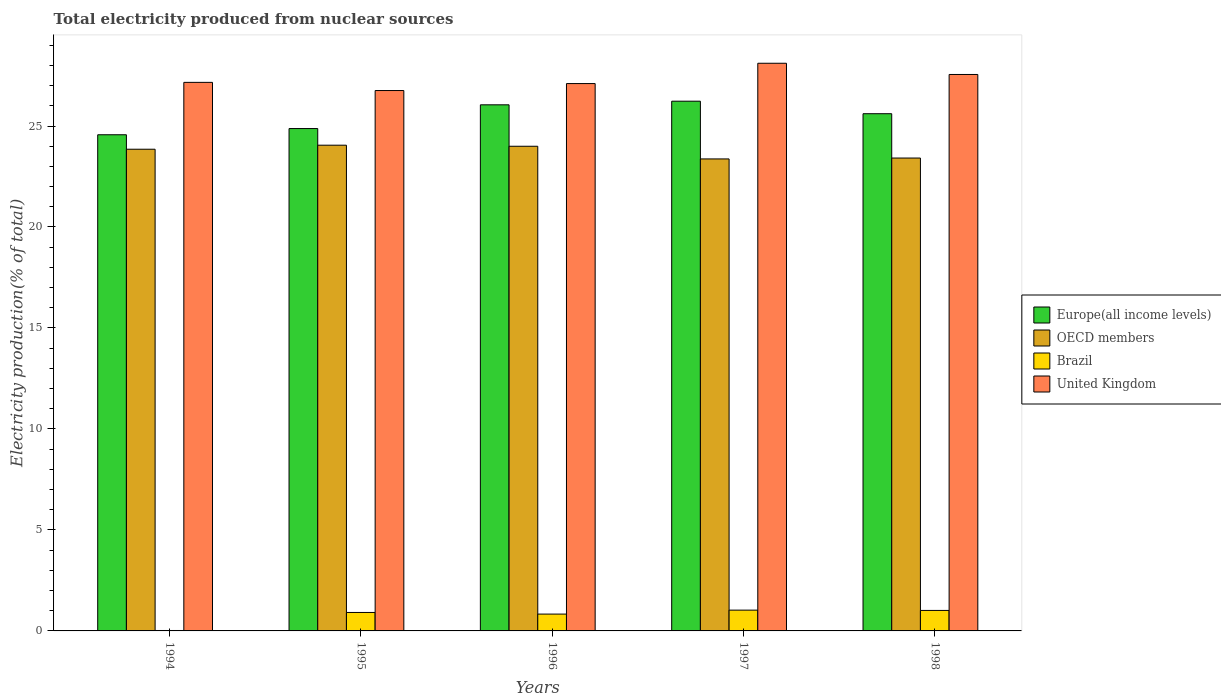How many bars are there on the 2nd tick from the right?
Keep it short and to the point. 4. What is the label of the 2nd group of bars from the left?
Ensure brevity in your answer.  1995. What is the total electricity produced in United Kingdom in 1994?
Provide a succinct answer. 27.16. Across all years, what is the maximum total electricity produced in OECD members?
Your answer should be very brief. 24.05. Across all years, what is the minimum total electricity produced in United Kingdom?
Keep it short and to the point. 26.76. In which year was the total electricity produced in Brazil maximum?
Provide a short and direct response. 1997. In which year was the total electricity produced in United Kingdom minimum?
Your response must be concise. 1995. What is the total total electricity produced in United Kingdom in the graph?
Provide a succinct answer. 136.68. What is the difference between the total electricity produced in OECD members in 1995 and that in 1998?
Provide a short and direct response. 0.64. What is the difference between the total electricity produced in Brazil in 1997 and the total electricity produced in OECD members in 1995?
Your answer should be very brief. -23.02. What is the average total electricity produced in Europe(all income levels) per year?
Ensure brevity in your answer.  25.47. In the year 1996, what is the difference between the total electricity produced in Europe(all income levels) and total electricity produced in OECD members?
Offer a terse response. 2.05. What is the ratio of the total electricity produced in Europe(all income levels) in 1995 to that in 1998?
Keep it short and to the point. 0.97. What is the difference between the highest and the second highest total electricity produced in United Kingdom?
Provide a succinct answer. 0.56. What is the difference between the highest and the lowest total electricity produced in Europe(all income levels)?
Offer a very short reply. 1.66. In how many years, is the total electricity produced in Europe(all income levels) greater than the average total electricity produced in Europe(all income levels) taken over all years?
Your answer should be compact. 3. Is the sum of the total electricity produced in OECD members in 1997 and 1998 greater than the maximum total electricity produced in Europe(all income levels) across all years?
Keep it short and to the point. Yes. What does the 1st bar from the left in 1996 represents?
Offer a terse response. Europe(all income levels). Is it the case that in every year, the sum of the total electricity produced in United Kingdom and total electricity produced in OECD members is greater than the total electricity produced in Brazil?
Ensure brevity in your answer.  Yes. How many bars are there?
Your response must be concise. 20. Are all the bars in the graph horizontal?
Make the answer very short. No. How many years are there in the graph?
Offer a very short reply. 5. Does the graph contain grids?
Make the answer very short. No. Where does the legend appear in the graph?
Keep it short and to the point. Center right. How are the legend labels stacked?
Make the answer very short. Vertical. What is the title of the graph?
Make the answer very short. Total electricity produced from nuclear sources. Does "Rwanda" appear as one of the legend labels in the graph?
Provide a succinct answer. No. What is the Electricity production(% of total) of Europe(all income levels) in 1994?
Your answer should be very brief. 24.57. What is the Electricity production(% of total) in OECD members in 1994?
Your answer should be very brief. 23.85. What is the Electricity production(% of total) in Brazil in 1994?
Provide a succinct answer. 0.02. What is the Electricity production(% of total) in United Kingdom in 1994?
Ensure brevity in your answer.  27.16. What is the Electricity production(% of total) of Europe(all income levels) in 1995?
Ensure brevity in your answer.  24.87. What is the Electricity production(% of total) in OECD members in 1995?
Give a very brief answer. 24.05. What is the Electricity production(% of total) in Brazil in 1995?
Provide a short and direct response. 0.91. What is the Electricity production(% of total) in United Kingdom in 1995?
Keep it short and to the point. 26.76. What is the Electricity production(% of total) in Europe(all income levels) in 1996?
Your answer should be compact. 26.05. What is the Electricity production(% of total) of OECD members in 1996?
Give a very brief answer. 24. What is the Electricity production(% of total) in Brazil in 1996?
Give a very brief answer. 0.83. What is the Electricity production(% of total) of United Kingdom in 1996?
Your answer should be compact. 27.1. What is the Electricity production(% of total) of Europe(all income levels) in 1997?
Ensure brevity in your answer.  26.23. What is the Electricity production(% of total) in OECD members in 1997?
Your answer should be compact. 23.37. What is the Electricity production(% of total) of Brazil in 1997?
Offer a terse response. 1.03. What is the Electricity production(% of total) in United Kingdom in 1997?
Make the answer very short. 28.11. What is the Electricity production(% of total) of Europe(all income levels) in 1998?
Ensure brevity in your answer.  25.61. What is the Electricity production(% of total) of OECD members in 1998?
Your response must be concise. 23.41. What is the Electricity production(% of total) in Brazil in 1998?
Offer a very short reply. 1.01. What is the Electricity production(% of total) in United Kingdom in 1998?
Make the answer very short. 27.55. Across all years, what is the maximum Electricity production(% of total) in Europe(all income levels)?
Your answer should be compact. 26.23. Across all years, what is the maximum Electricity production(% of total) in OECD members?
Provide a short and direct response. 24.05. Across all years, what is the maximum Electricity production(% of total) in Brazil?
Provide a succinct answer. 1.03. Across all years, what is the maximum Electricity production(% of total) of United Kingdom?
Your response must be concise. 28.11. Across all years, what is the minimum Electricity production(% of total) of Europe(all income levels)?
Your response must be concise. 24.57. Across all years, what is the minimum Electricity production(% of total) in OECD members?
Ensure brevity in your answer.  23.37. Across all years, what is the minimum Electricity production(% of total) in Brazil?
Give a very brief answer. 0.02. Across all years, what is the minimum Electricity production(% of total) of United Kingdom?
Offer a terse response. 26.76. What is the total Electricity production(% of total) of Europe(all income levels) in the graph?
Ensure brevity in your answer.  127.33. What is the total Electricity production(% of total) of OECD members in the graph?
Give a very brief answer. 118.68. What is the total Electricity production(% of total) of Brazil in the graph?
Provide a succinct answer. 3.81. What is the total Electricity production(% of total) of United Kingdom in the graph?
Offer a very short reply. 136.68. What is the difference between the Electricity production(% of total) of Europe(all income levels) in 1994 and that in 1995?
Your answer should be very brief. -0.31. What is the difference between the Electricity production(% of total) of OECD members in 1994 and that in 1995?
Make the answer very short. -0.2. What is the difference between the Electricity production(% of total) of Brazil in 1994 and that in 1995?
Offer a very short reply. -0.89. What is the difference between the Electricity production(% of total) of United Kingdom in 1994 and that in 1995?
Offer a very short reply. 0.4. What is the difference between the Electricity production(% of total) of Europe(all income levels) in 1994 and that in 1996?
Ensure brevity in your answer.  -1.48. What is the difference between the Electricity production(% of total) in OECD members in 1994 and that in 1996?
Your answer should be compact. -0.15. What is the difference between the Electricity production(% of total) of Brazil in 1994 and that in 1996?
Your response must be concise. -0.81. What is the difference between the Electricity production(% of total) in United Kingdom in 1994 and that in 1996?
Your answer should be compact. 0.06. What is the difference between the Electricity production(% of total) in Europe(all income levels) in 1994 and that in 1997?
Give a very brief answer. -1.66. What is the difference between the Electricity production(% of total) of OECD members in 1994 and that in 1997?
Your answer should be very brief. 0.48. What is the difference between the Electricity production(% of total) in Brazil in 1994 and that in 1997?
Provide a succinct answer. -1.01. What is the difference between the Electricity production(% of total) of United Kingdom in 1994 and that in 1997?
Provide a succinct answer. -0.95. What is the difference between the Electricity production(% of total) in Europe(all income levels) in 1994 and that in 1998?
Your answer should be compact. -1.04. What is the difference between the Electricity production(% of total) in OECD members in 1994 and that in 1998?
Offer a terse response. 0.44. What is the difference between the Electricity production(% of total) in Brazil in 1994 and that in 1998?
Your answer should be compact. -0.99. What is the difference between the Electricity production(% of total) of United Kingdom in 1994 and that in 1998?
Make the answer very short. -0.39. What is the difference between the Electricity production(% of total) in Europe(all income levels) in 1995 and that in 1996?
Offer a terse response. -1.18. What is the difference between the Electricity production(% of total) of OECD members in 1995 and that in 1996?
Your response must be concise. 0.05. What is the difference between the Electricity production(% of total) in Brazil in 1995 and that in 1996?
Provide a short and direct response. 0.08. What is the difference between the Electricity production(% of total) of United Kingdom in 1995 and that in 1996?
Your answer should be compact. -0.35. What is the difference between the Electricity production(% of total) in Europe(all income levels) in 1995 and that in 1997?
Offer a terse response. -1.35. What is the difference between the Electricity production(% of total) of OECD members in 1995 and that in 1997?
Make the answer very short. 0.68. What is the difference between the Electricity production(% of total) of Brazil in 1995 and that in 1997?
Make the answer very short. -0.12. What is the difference between the Electricity production(% of total) of United Kingdom in 1995 and that in 1997?
Ensure brevity in your answer.  -1.35. What is the difference between the Electricity production(% of total) of Europe(all income levels) in 1995 and that in 1998?
Your answer should be very brief. -0.74. What is the difference between the Electricity production(% of total) of OECD members in 1995 and that in 1998?
Offer a very short reply. 0.64. What is the difference between the Electricity production(% of total) of Brazil in 1995 and that in 1998?
Provide a short and direct response. -0.1. What is the difference between the Electricity production(% of total) of United Kingdom in 1995 and that in 1998?
Give a very brief answer. -0.8. What is the difference between the Electricity production(% of total) in Europe(all income levels) in 1996 and that in 1997?
Offer a terse response. -0.18. What is the difference between the Electricity production(% of total) of OECD members in 1996 and that in 1997?
Provide a short and direct response. 0.63. What is the difference between the Electricity production(% of total) of Brazil in 1996 and that in 1997?
Offer a terse response. -0.2. What is the difference between the Electricity production(% of total) of United Kingdom in 1996 and that in 1997?
Your response must be concise. -1.01. What is the difference between the Electricity production(% of total) of Europe(all income levels) in 1996 and that in 1998?
Your answer should be very brief. 0.44. What is the difference between the Electricity production(% of total) of OECD members in 1996 and that in 1998?
Your answer should be very brief. 0.58. What is the difference between the Electricity production(% of total) in Brazil in 1996 and that in 1998?
Offer a terse response. -0.18. What is the difference between the Electricity production(% of total) in United Kingdom in 1996 and that in 1998?
Your response must be concise. -0.45. What is the difference between the Electricity production(% of total) in Europe(all income levels) in 1997 and that in 1998?
Your response must be concise. 0.62. What is the difference between the Electricity production(% of total) of OECD members in 1997 and that in 1998?
Offer a terse response. -0.04. What is the difference between the Electricity production(% of total) of Brazil in 1997 and that in 1998?
Offer a terse response. 0.01. What is the difference between the Electricity production(% of total) in United Kingdom in 1997 and that in 1998?
Your answer should be very brief. 0.56. What is the difference between the Electricity production(% of total) in Europe(all income levels) in 1994 and the Electricity production(% of total) in OECD members in 1995?
Your answer should be compact. 0.52. What is the difference between the Electricity production(% of total) in Europe(all income levels) in 1994 and the Electricity production(% of total) in Brazil in 1995?
Make the answer very short. 23.65. What is the difference between the Electricity production(% of total) of Europe(all income levels) in 1994 and the Electricity production(% of total) of United Kingdom in 1995?
Your answer should be very brief. -2.19. What is the difference between the Electricity production(% of total) of OECD members in 1994 and the Electricity production(% of total) of Brazil in 1995?
Provide a succinct answer. 22.94. What is the difference between the Electricity production(% of total) of OECD members in 1994 and the Electricity production(% of total) of United Kingdom in 1995?
Give a very brief answer. -2.91. What is the difference between the Electricity production(% of total) in Brazil in 1994 and the Electricity production(% of total) in United Kingdom in 1995?
Your response must be concise. -26.74. What is the difference between the Electricity production(% of total) in Europe(all income levels) in 1994 and the Electricity production(% of total) in OECD members in 1996?
Your answer should be compact. 0.57. What is the difference between the Electricity production(% of total) of Europe(all income levels) in 1994 and the Electricity production(% of total) of Brazil in 1996?
Provide a short and direct response. 23.73. What is the difference between the Electricity production(% of total) of Europe(all income levels) in 1994 and the Electricity production(% of total) of United Kingdom in 1996?
Offer a terse response. -2.53. What is the difference between the Electricity production(% of total) of OECD members in 1994 and the Electricity production(% of total) of Brazil in 1996?
Offer a terse response. 23.02. What is the difference between the Electricity production(% of total) of OECD members in 1994 and the Electricity production(% of total) of United Kingdom in 1996?
Your answer should be compact. -3.25. What is the difference between the Electricity production(% of total) in Brazil in 1994 and the Electricity production(% of total) in United Kingdom in 1996?
Your response must be concise. -27.08. What is the difference between the Electricity production(% of total) of Europe(all income levels) in 1994 and the Electricity production(% of total) of OECD members in 1997?
Offer a very short reply. 1.2. What is the difference between the Electricity production(% of total) in Europe(all income levels) in 1994 and the Electricity production(% of total) in Brazil in 1997?
Offer a very short reply. 23.54. What is the difference between the Electricity production(% of total) in Europe(all income levels) in 1994 and the Electricity production(% of total) in United Kingdom in 1997?
Your answer should be compact. -3.54. What is the difference between the Electricity production(% of total) of OECD members in 1994 and the Electricity production(% of total) of Brazil in 1997?
Your answer should be compact. 22.82. What is the difference between the Electricity production(% of total) of OECD members in 1994 and the Electricity production(% of total) of United Kingdom in 1997?
Your response must be concise. -4.26. What is the difference between the Electricity production(% of total) in Brazil in 1994 and the Electricity production(% of total) in United Kingdom in 1997?
Provide a succinct answer. -28.09. What is the difference between the Electricity production(% of total) of Europe(all income levels) in 1994 and the Electricity production(% of total) of OECD members in 1998?
Offer a terse response. 1.15. What is the difference between the Electricity production(% of total) in Europe(all income levels) in 1994 and the Electricity production(% of total) in Brazil in 1998?
Your answer should be very brief. 23.55. What is the difference between the Electricity production(% of total) of Europe(all income levels) in 1994 and the Electricity production(% of total) of United Kingdom in 1998?
Your answer should be very brief. -2.98. What is the difference between the Electricity production(% of total) of OECD members in 1994 and the Electricity production(% of total) of Brazil in 1998?
Provide a short and direct response. 22.84. What is the difference between the Electricity production(% of total) in OECD members in 1994 and the Electricity production(% of total) in United Kingdom in 1998?
Offer a very short reply. -3.7. What is the difference between the Electricity production(% of total) of Brazil in 1994 and the Electricity production(% of total) of United Kingdom in 1998?
Provide a succinct answer. -27.53. What is the difference between the Electricity production(% of total) of Europe(all income levels) in 1995 and the Electricity production(% of total) of OECD members in 1996?
Offer a very short reply. 0.88. What is the difference between the Electricity production(% of total) of Europe(all income levels) in 1995 and the Electricity production(% of total) of Brazil in 1996?
Offer a very short reply. 24.04. What is the difference between the Electricity production(% of total) of Europe(all income levels) in 1995 and the Electricity production(% of total) of United Kingdom in 1996?
Your response must be concise. -2.23. What is the difference between the Electricity production(% of total) of OECD members in 1995 and the Electricity production(% of total) of Brazil in 1996?
Your answer should be compact. 23.22. What is the difference between the Electricity production(% of total) in OECD members in 1995 and the Electricity production(% of total) in United Kingdom in 1996?
Your answer should be very brief. -3.05. What is the difference between the Electricity production(% of total) of Brazil in 1995 and the Electricity production(% of total) of United Kingdom in 1996?
Your response must be concise. -26.19. What is the difference between the Electricity production(% of total) of Europe(all income levels) in 1995 and the Electricity production(% of total) of OECD members in 1997?
Your response must be concise. 1.5. What is the difference between the Electricity production(% of total) of Europe(all income levels) in 1995 and the Electricity production(% of total) of Brazil in 1997?
Offer a terse response. 23.85. What is the difference between the Electricity production(% of total) of Europe(all income levels) in 1995 and the Electricity production(% of total) of United Kingdom in 1997?
Keep it short and to the point. -3.23. What is the difference between the Electricity production(% of total) in OECD members in 1995 and the Electricity production(% of total) in Brazil in 1997?
Provide a succinct answer. 23.02. What is the difference between the Electricity production(% of total) in OECD members in 1995 and the Electricity production(% of total) in United Kingdom in 1997?
Offer a very short reply. -4.06. What is the difference between the Electricity production(% of total) in Brazil in 1995 and the Electricity production(% of total) in United Kingdom in 1997?
Your answer should be compact. -27.19. What is the difference between the Electricity production(% of total) in Europe(all income levels) in 1995 and the Electricity production(% of total) in OECD members in 1998?
Offer a terse response. 1.46. What is the difference between the Electricity production(% of total) in Europe(all income levels) in 1995 and the Electricity production(% of total) in Brazil in 1998?
Offer a terse response. 23.86. What is the difference between the Electricity production(% of total) in Europe(all income levels) in 1995 and the Electricity production(% of total) in United Kingdom in 1998?
Provide a short and direct response. -2.68. What is the difference between the Electricity production(% of total) of OECD members in 1995 and the Electricity production(% of total) of Brazil in 1998?
Provide a succinct answer. 23.04. What is the difference between the Electricity production(% of total) in OECD members in 1995 and the Electricity production(% of total) in United Kingdom in 1998?
Ensure brevity in your answer.  -3.5. What is the difference between the Electricity production(% of total) of Brazil in 1995 and the Electricity production(% of total) of United Kingdom in 1998?
Make the answer very short. -26.64. What is the difference between the Electricity production(% of total) of Europe(all income levels) in 1996 and the Electricity production(% of total) of OECD members in 1997?
Provide a short and direct response. 2.68. What is the difference between the Electricity production(% of total) of Europe(all income levels) in 1996 and the Electricity production(% of total) of Brazil in 1997?
Your answer should be compact. 25.02. What is the difference between the Electricity production(% of total) in Europe(all income levels) in 1996 and the Electricity production(% of total) in United Kingdom in 1997?
Your response must be concise. -2.06. What is the difference between the Electricity production(% of total) in OECD members in 1996 and the Electricity production(% of total) in Brazil in 1997?
Ensure brevity in your answer.  22.97. What is the difference between the Electricity production(% of total) of OECD members in 1996 and the Electricity production(% of total) of United Kingdom in 1997?
Make the answer very short. -4.11. What is the difference between the Electricity production(% of total) of Brazil in 1996 and the Electricity production(% of total) of United Kingdom in 1997?
Ensure brevity in your answer.  -27.27. What is the difference between the Electricity production(% of total) of Europe(all income levels) in 1996 and the Electricity production(% of total) of OECD members in 1998?
Offer a very short reply. 2.63. What is the difference between the Electricity production(% of total) in Europe(all income levels) in 1996 and the Electricity production(% of total) in Brazil in 1998?
Make the answer very short. 25.04. What is the difference between the Electricity production(% of total) of Europe(all income levels) in 1996 and the Electricity production(% of total) of United Kingdom in 1998?
Your answer should be compact. -1.5. What is the difference between the Electricity production(% of total) of OECD members in 1996 and the Electricity production(% of total) of Brazil in 1998?
Offer a terse response. 22.98. What is the difference between the Electricity production(% of total) in OECD members in 1996 and the Electricity production(% of total) in United Kingdom in 1998?
Offer a very short reply. -3.55. What is the difference between the Electricity production(% of total) of Brazil in 1996 and the Electricity production(% of total) of United Kingdom in 1998?
Make the answer very short. -26.72. What is the difference between the Electricity production(% of total) in Europe(all income levels) in 1997 and the Electricity production(% of total) in OECD members in 1998?
Your answer should be very brief. 2.81. What is the difference between the Electricity production(% of total) of Europe(all income levels) in 1997 and the Electricity production(% of total) of Brazil in 1998?
Provide a short and direct response. 25.21. What is the difference between the Electricity production(% of total) of Europe(all income levels) in 1997 and the Electricity production(% of total) of United Kingdom in 1998?
Ensure brevity in your answer.  -1.32. What is the difference between the Electricity production(% of total) in OECD members in 1997 and the Electricity production(% of total) in Brazil in 1998?
Offer a terse response. 22.36. What is the difference between the Electricity production(% of total) of OECD members in 1997 and the Electricity production(% of total) of United Kingdom in 1998?
Offer a very short reply. -4.18. What is the difference between the Electricity production(% of total) in Brazil in 1997 and the Electricity production(% of total) in United Kingdom in 1998?
Ensure brevity in your answer.  -26.52. What is the average Electricity production(% of total) of Europe(all income levels) per year?
Offer a very short reply. 25.47. What is the average Electricity production(% of total) in OECD members per year?
Your answer should be very brief. 23.74. What is the average Electricity production(% of total) of Brazil per year?
Offer a very short reply. 0.76. What is the average Electricity production(% of total) in United Kingdom per year?
Keep it short and to the point. 27.34. In the year 1994, what is the difference between the Electricity production(% of total) in Europe(all income levels) and Electricity production(% of total) in OECD members?
Your response must be concise. 0.72. In the year 1994, what is the difference between the Electricity production(% of total) in Europe(all income levels) and Electricity production(% of total) in Brazil?
Your answer should be very brief. 24.55. In the year 1994, what is the difference between the Electricity production(% of total) of Europe(all income levels) and Electricity production(% of total) of United Kingdom?
Keep it short and to the point. -2.59. In the year 1994, what is the difference between the Electricity production(% of total) of OECD members and Electricity production(% of total) of Brazil?
Offer a terse response. 23.83. In the year 1994, what is the difference between the Electricity production(% of total) of OECD members and Electricity production(% of total) of United Kingdom?
Keep it short and to the point. -3.31. In the year 1994, what is the difference between the Electricity production(% of total) of Brazil and Electricity production(% of total) of United Kingdom?
Your response must be concise. -27.14. In the year 1995, what is the difference between the Electricity production(% of total) in Europe(all income levels) and Electricity production(% of total) in OECD members?
Provide a succinct answer. 0.82. In the year 1995, what is the difference between the Electricity production(% of total) in Europe(all income levels) and Electricity production(% of total) in Brazil?
Make the answer very short. 23.96. In the year 1995, what is the difference between the Electricity production(% of total) in Europe(all income levels) and Electricity production(% of total) in United Kingdom?
Ensure brevity in your answer.  -1.88. In the year 1995, what is the difference between the Electricity production(% of total) of OECD members and Electricity production(% of total) of Brazil?
Your answer should be very brief. 23.14. In the year 1995, what is the difference between the Electricity production(% of total) of OECD members and Electricity production(% of total) of United Kingdom?
Your response must be concise. -2.71. In the year 1995, what is the difference between the Electricity production(% of total) in Brazil and Electricity production(% of total) in United Kingdom?
Offer a terse response. -25.84. In the year 1996, what is the difference between the Electricity production(% of total) of Europe(all income levels) and Electricity production(% of total) of OECD members?
Provide a succinct answer. 2.05. In the year 1996, what is the difference between the Electricity production(% of total) of Europe(all income levels) and Electricity production(% of total) of Brazil?
Provide a short and direct response. 25.22. In the year 1996, what is the difference between the Electricity production(% of total) in Europe(all income levels) and Electricity production(% of total) in United Kingdom?
Ensure brevity in your answer.  -1.05. In the year 1996, what is the difference between the Electricity production(% of total) of OECD members and Electricity production(% of total) of Brazil?
Your response must be concise. 23.16. In the year 1996, what is the difference between the Electricity production(% of total) in OECD members and Electricity production(% of total) in United Kingdom?
Ensure brevity in your answer.  -3.1. In the year 1996, what is the difference between the Electricity production(% of total) of Brazil and Electricity production(% of total) of United Kingdom?
Make the answer very short. -26.27. In the year 1997, what is the difference between the Electricity production(% of total) in Europe(all income levels) and Electricity production(% of total) in OECD members?
Offer a terse response. 2.86. In the year 1997, what is the difference between the Electricity production(% of total) of Europe(all income levels) and Electricity production(% of total) of Brazil?
Provide a succinct answer. 25.2. In the year 1997, what is the difference between the Electricity production(% of total) in Europe(all income levels) and Electricity production(% of total) in United Kingdom?
Offer a very short reply. -1.88. In the year 1997, what is the difference between the Electricity production(% of total) of OECD members and Electricity production(% of total) of Brazil?
Keep it short and to the point. 22.34. In the year 1997, what is the difference between the Electricity production(% of total) in OECD members and Electricity production(% of total) in United Kingdom?
Keep it short and to the point. -4.74. In the year 1997, what is the difference between the Electricity production(% of total) of Brazil and Electricity production(% of total) of United Kingdom?
Offer a very short reply. -27.08. In the year 1998, what is the difference between the Electricity production(% of total) of Europe(all income levels) and Electricity production(% of total) of OECD members?
Provide a succinct answer. 2.19. In the year 1998, what is the difference between the Electricity production(% of total) in Europe(all income levels) and Electricity production(% of total) in Brazil?
Offer a very short reply. 24.59. In the year 1998, what is the difference between the Electricity production(% of total) in Europe(all income levels) and Electricity production(% of total) in United Kingdom?
Keep it short and to the point. -1.94. In the year 1998, what is the difference between the Electricity production(% of total) in OECD members and Electricity production(% of total) in Brazil?
Your answer should be compact. 22.4. In the year 1998, what is the difference between the Electricity production(% of total) in OECD members and Electricity production(% of total) in United Kingdom?
Your answer should be compact. -4.14. In the year 1998, what is the difference between the Electricity production(% of total) in Brazil and Electricity production(% of total) in United Kingdom?
Give a very brief answer. -26.54. What is the ratio of the Electricity production(% of total) in Europe(all income levels) in 1994 to that in 1995?
Give a very brief answer. 0.99. What is the ratio of the Electricity production(% of total) in Brazil in 1994 to that in 1995?
Provide a short and direct response. 0.02. What is the ratio of the Electricity production(% of total) in United Kingdom in 1994 to that in 1995?
Offer a very short reply. 1.02. What is the ratio of the Electricity production(% of total) in Europe(all income levels) in 1994 to that in 1996?
Your response must be concise. 0.94. What is the ratio of the Electricity production(% of total) in Brazil in 1994 to that in 1996?
Ensure brevity in your answer.  0.03. What is the ratio of the Electricity production(% of total) of United Kingdom in 1994 to that in 1996?
Offer a very short reply. 1. What is the ratio of the Electricity production(% of total) in Europe(all income levels) in 1994 to that in 1997?
Provide a succinct answer. 0.94. What is the ratio of the Electricity production(% of total) of OECD members in 1994 to that in 1997?
Offer a terse response. 1.02. What is the ratio of the Electricity production(% of total) in Brazil in 1994 to that in 1997?
Your response must be concise. 0.02. What is the ratio of the Electricity production(% of total) of United Kingdom in 1994 to that in 1997?
Provide a short and direct response. 0.97. What is the ratio of the Electricity production(% of total) in Europe(all income levels) in 1994 to that in 1998?
Give a very brief answer. 0.96. What is the ratio of the Electricity production(% of total) of OECD members in 1994 to that in 1998?
Your answer should be very brief. 1.02. What is the ratio of the Electricity production(% of total) of Brazil in 1994 to that in 1998?
Provide a short and direct response. 0.02. What is the ratio of the Electricity production(% of total) of United Kingdom in 1994 to that in 1998?
Offer a very short reply. 0.99. What is the ratio of the Electricity production(% of total) of Europe(all income levels) in 1995 to that in 1996?
Keep it short and to the point. 0.95. What is the ratio of the Electricity production(% of total) of Brazil in 1995 to that in 1996?
Make the answer very short. 1.1. What is the ratio of the Electricity production(% of total) in United Kingdom in 1995 to that in 1996?
Your response must be concise. 0.99. What is the ratio of the Electricity production(% of total) of Europe(all income levels) in 1995 to that in 1997?
Provide a succinct answer. 0.95. What is the ratio of the Electricity production(% of total) of OECD members in 1995 to that in 1997?
Provide a succinct answer. 1.03. What is the ratio of the Electricity production(% of total) in Brazil in 1995 to that in 1997?
Offer a very short reply. 0.89. What is the ratio of the Electricity production(% of total) of United Kingdom in 1995 to that in 1997?
Keep it short and to the point. 0.95. What is the ratio of the Electricity production(% of total) of Europe(all income levels) in 1995 to that in 1998?
Provide a succinct answer. 0.97. What is the ratio of the Electricity production(% of total) of OECD members in 1995 to that in 1998?
Ensure brevity in your answer.  1.03. What is the ratio of the Electricity production(% of total) of Brazil in 1995 to that in 1998?
Offer a very short reply. 0.9. What is the ratio of the Electricity production(% of total) of United Kingdom in 1995 to that in 1998?
Provide a short and direct response. 0.97. What is the ratio of the Electricity production(% of total) of Europe(all income levels) in 1996 to that in 1997?
Ensure brevity in your answer.  0.99. What is the ratio of the Electricity production(% of total) in OECD members in 1996 to that in 1997?
Your response must be concise. 1.03. What is the ratio of the Electricity production(% of total) in Brazil in 1996 to that in 1997?
Offer a terse response. 0.81. What is the ratio of the Electricity production(% of total) of United Kingdom in 1996 to that in 1997?
Offer a very short reply. 0.96. What is the ratio of the Electricity production(% of total) of Europe(all income levels) in 1996 to that in 1998?
Provide a short and direct response. 1.02. What is the ratio of the Electricity production(% of total) of OECD members in 1996 to that in 1998?
Your answer should be very brief. 1.02. What is the ratio of the Electricity production(% of total) in Brazil in 1996 to that in 1998?
Your answer should be very brief. 0.82. What is the ratio of the Electricity production(% of total) of United Kingdom in 1996 to that in 1998?
Provide a short and direct response. 0.98. What is the ratio of the Electricity production(% of total) in Europe(all income levels) in 1997 to that in 1998?
Your answer should be very brief. 1.02. What is the ratio of the Electricity production(% of total) of Brazil in 1997 to that in 1998?
Keep it short and to the point. 1.01. What is the ratio of the Electricity production(% of total) of United Kingdom in 1997 to that in 1998?
Provide a succinct answer. 1.02. What is the difference between the highest and the second highest Electricity production(% of total) in Europe(all income levels)?
Your answer should be compact. 0.18. What is the difference between the highest and the second highest Electricity production(% of total) of OECD members?
Offer a terse response. 0.05. What is the difference between the highest and the second highest Electricity production(% of total) of Brazil?
Offer a terse response. 0.01. What is the difference between the highest and the second highest Electricity production(% of total) in United Kingdom?
Offer a very short reply. 0.56. What is the difference between the highest and the lowest Electricity production(% of total) in Europe(all income levels)?
Your response must be concise. 1.66. What is the difference between the highest and the lowest Electricity production(% of total) of OECD members?
Provide a succinct answer. 0.68. What is the difference between the highest and the lowest Electricity production(% of total) in Brazil?
Your answer should be very brief. 1.01. What is the difference between the highest and the lowest Electricity production(% of total) in United Kingdom?
Offer a very short reply. 1.35. 